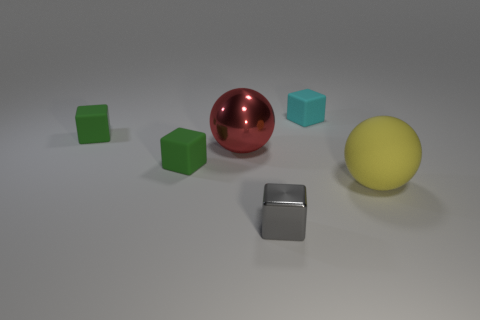There is another yellow object that is the same shape as the large shiny object; what is its material?
Offer a very short reply. Rubber. Are there any yellow spheres that have the same material as the cyan object?
Offer a very short reply. Yes. Does the yellow matte object have the same shape as the metal object behind the large yellow sphere?
Your answer should be very brief. Yes. What number of things are right of the big red thing and in front of the tiny cyan cube?
Provide a succinct answer. 2. Does the yellow sphere have the same material as the large thing that is on the left side of the gray metal cube?
Your answer should be very brief. No. Are there an equal number of big yellow matte spheres that are left of the large yellow matte object and purple metal blocks?
Your response must be concise. Yes. What color is the ball that is in front of the large red metal object?
Ensure brevity in your answer.  Yellow. What number of other things are there of the same color as the tiny metal block?
Your answer should be compact. 0. There is a metal thing behind the rubber sphere; does it have the same size as the large yellow matte thing?
Ensure brevity in your answer.  Yes. What is the small object in front of the large rubber sphere made of?
Your answer should be compact. Metal. 